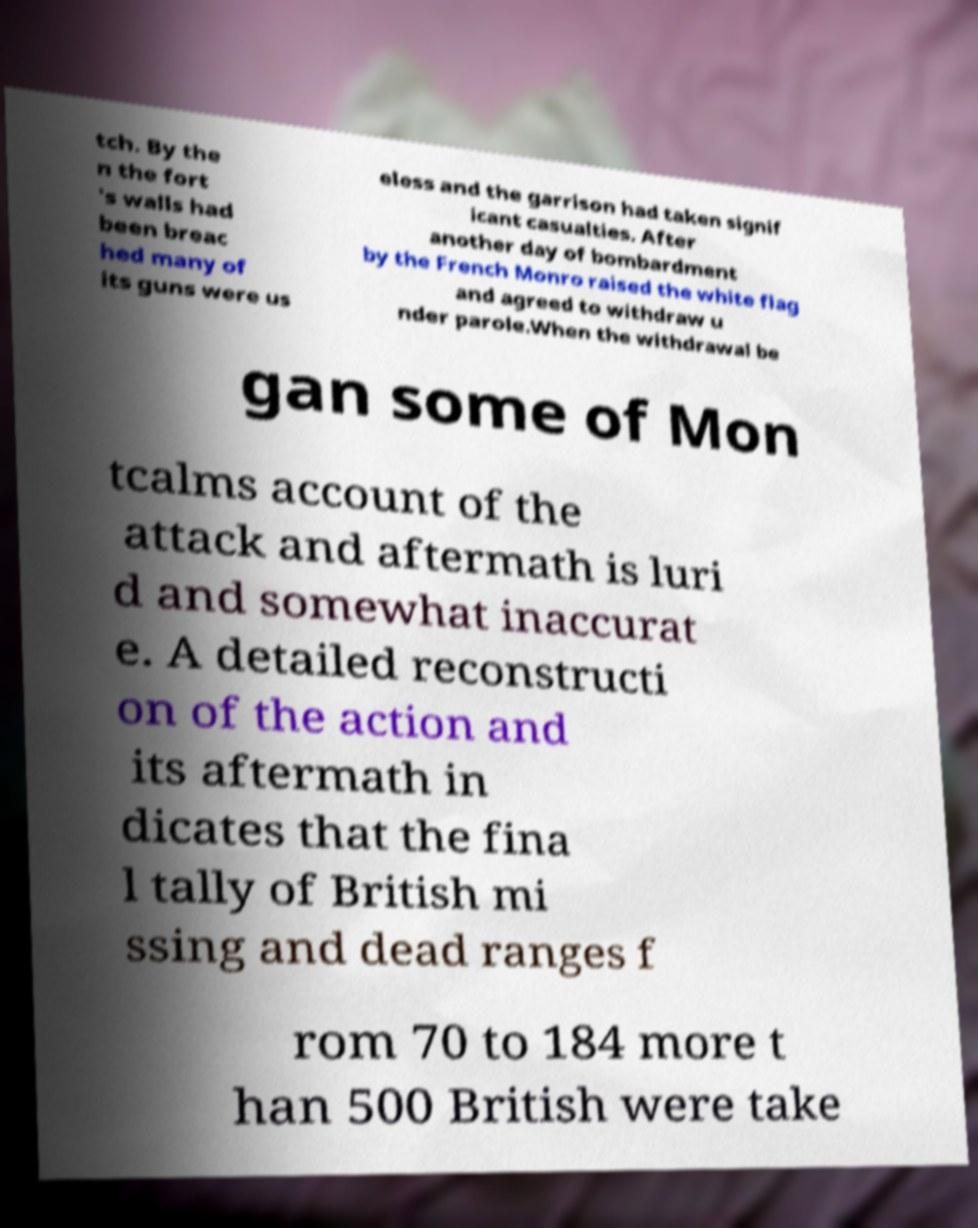For documentation purposes, I need the text within this image transcribed. Could you provide that? tch. By the n the fort 's walls had been breac hed many of its guns were us eless and the garrison had taken signif icant casualties. After another day of bombardment by the French Monro raised the white flag and agreed to withdraw u nder parole.When the withdrawal be gan some of Mon tcalms account of the attack and aftermath is luri d and somewhat inaccurat e. A detailed reconstructi on of the action and its aftermath in dicates that the fina l tally of British mi ssing and dead ranges f rom 70 to 184 more t han 500 British were take 